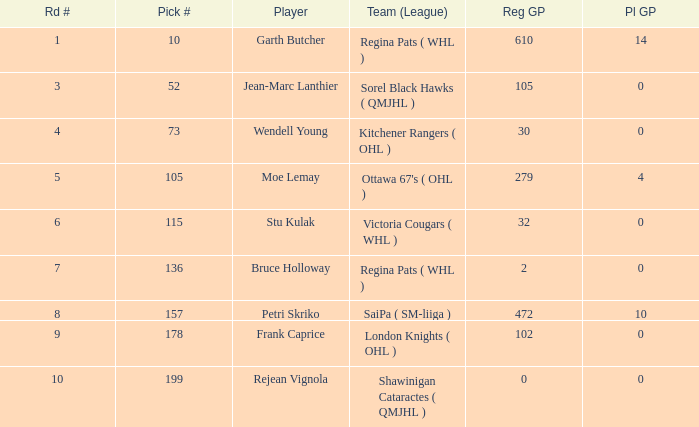What is the mean road number when Moe Lemay is the player? 5.0. 